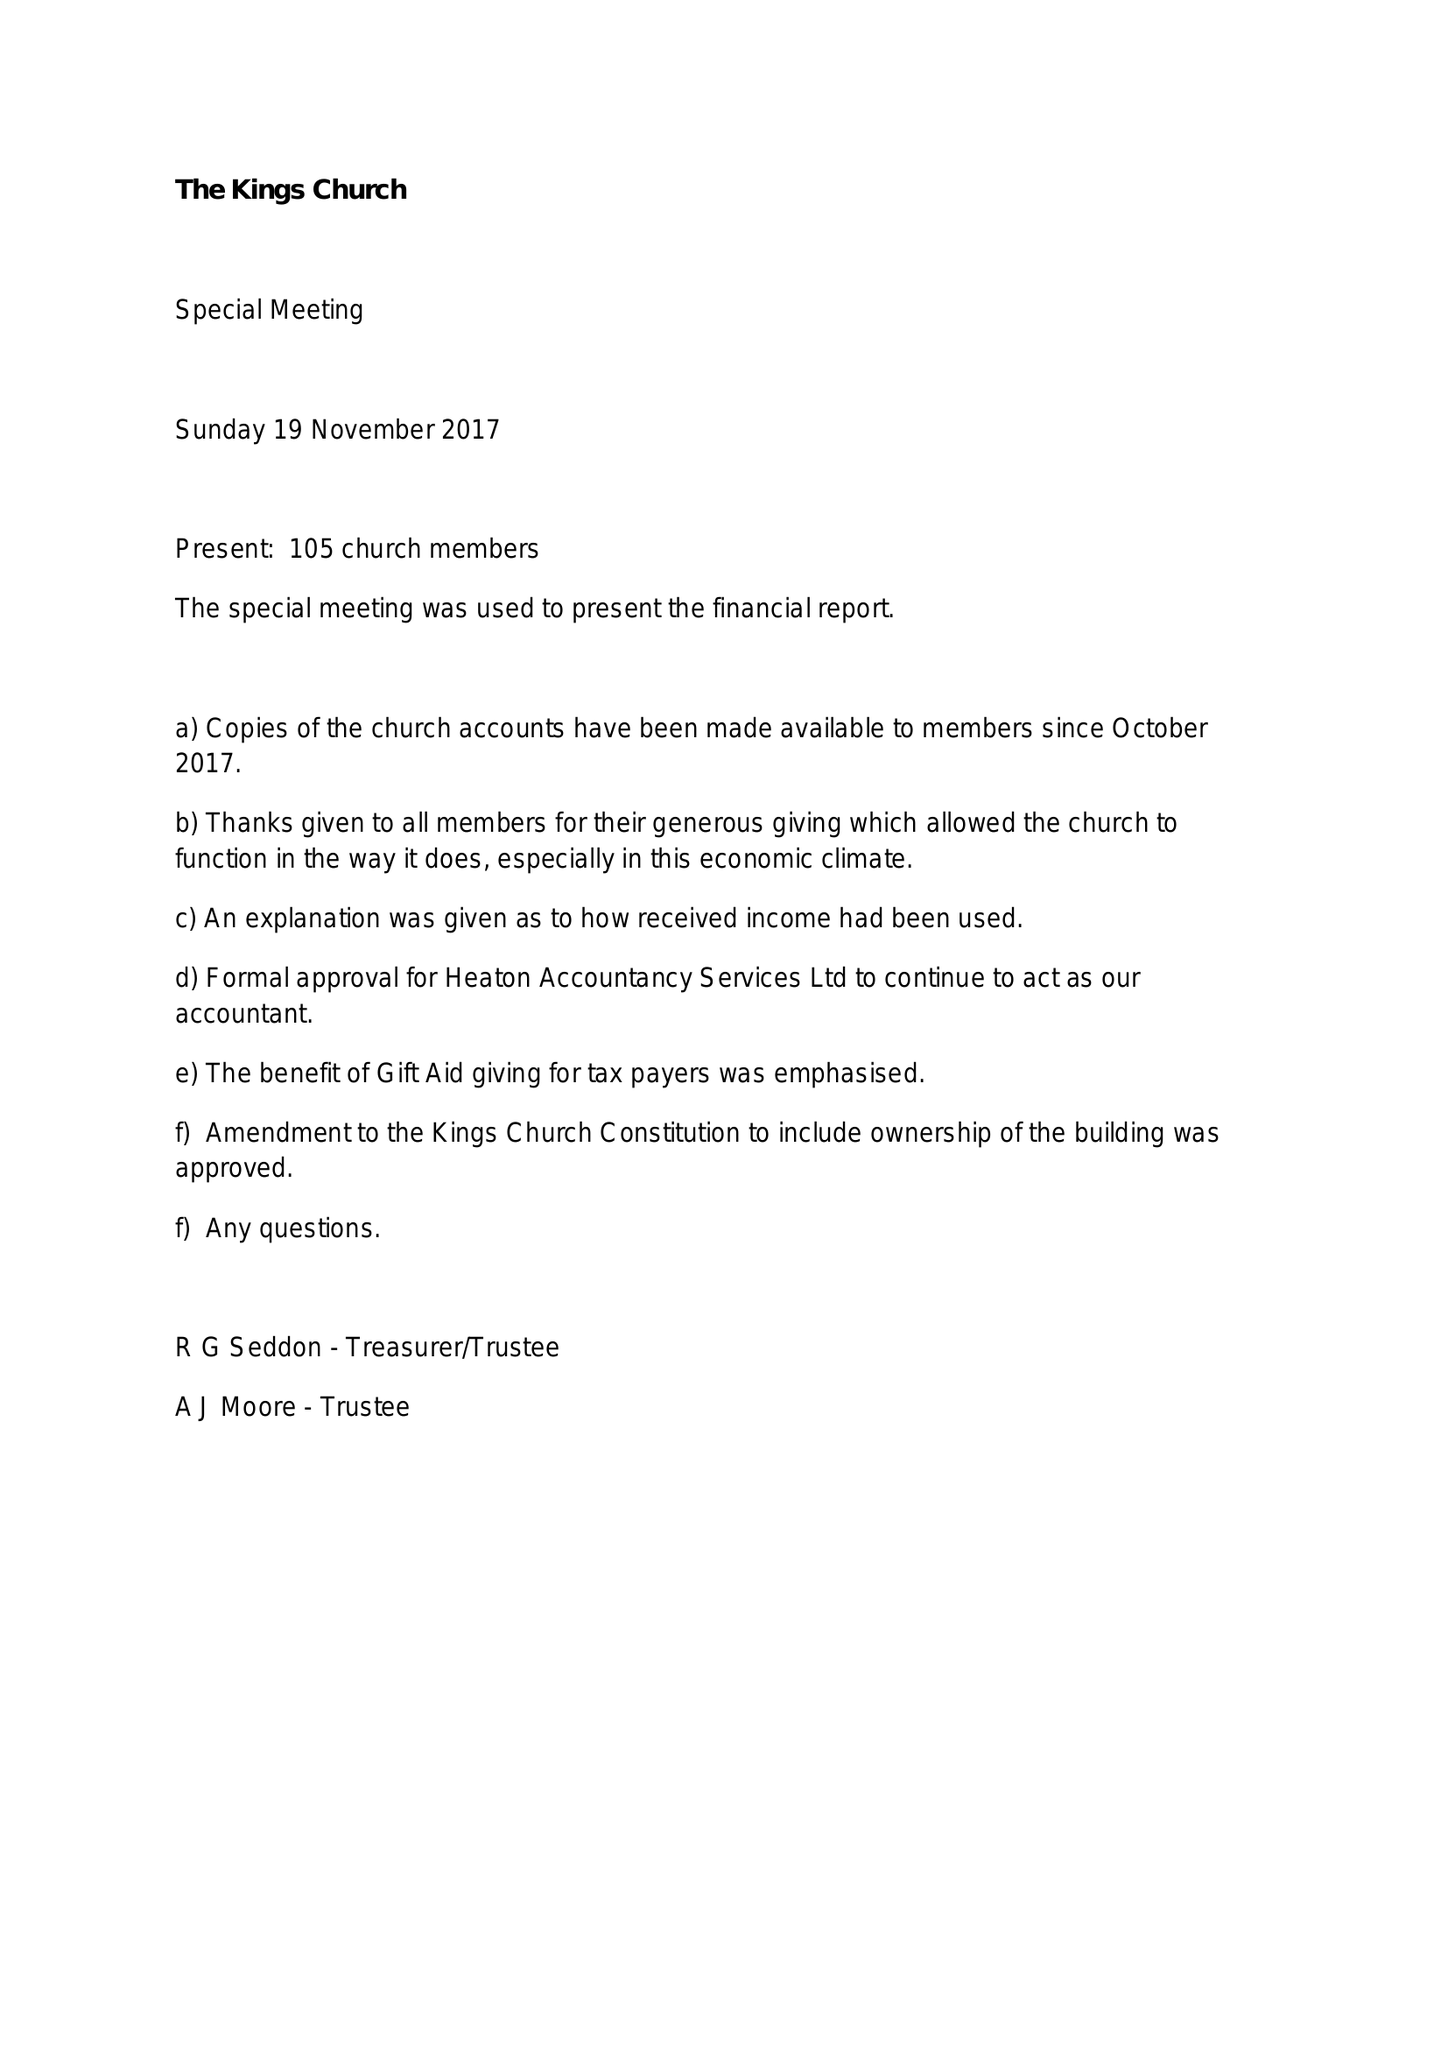What is the value for the report_date?
Answer the question using a single word or phrase. 2017-03-31 